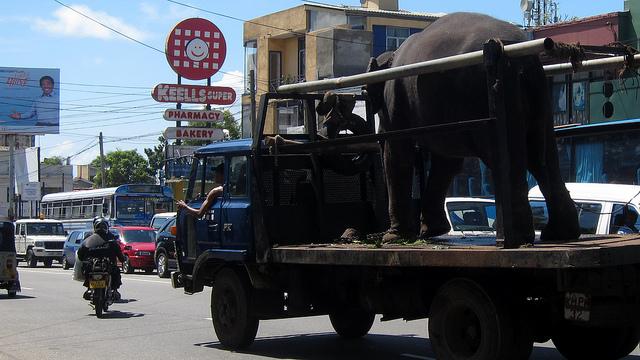Is the animal in its natural habitat?
Short answer required. No. Why is the elephant on a truck?
Concise answer only. Traveling. Is everyone wearing something on their head?
Short answer required. Yes. What is the man on the motorcycle looking at?
Keep it brief. Traffic. How did they get the elephant on the truck?
Answer briefly. Ramp. 